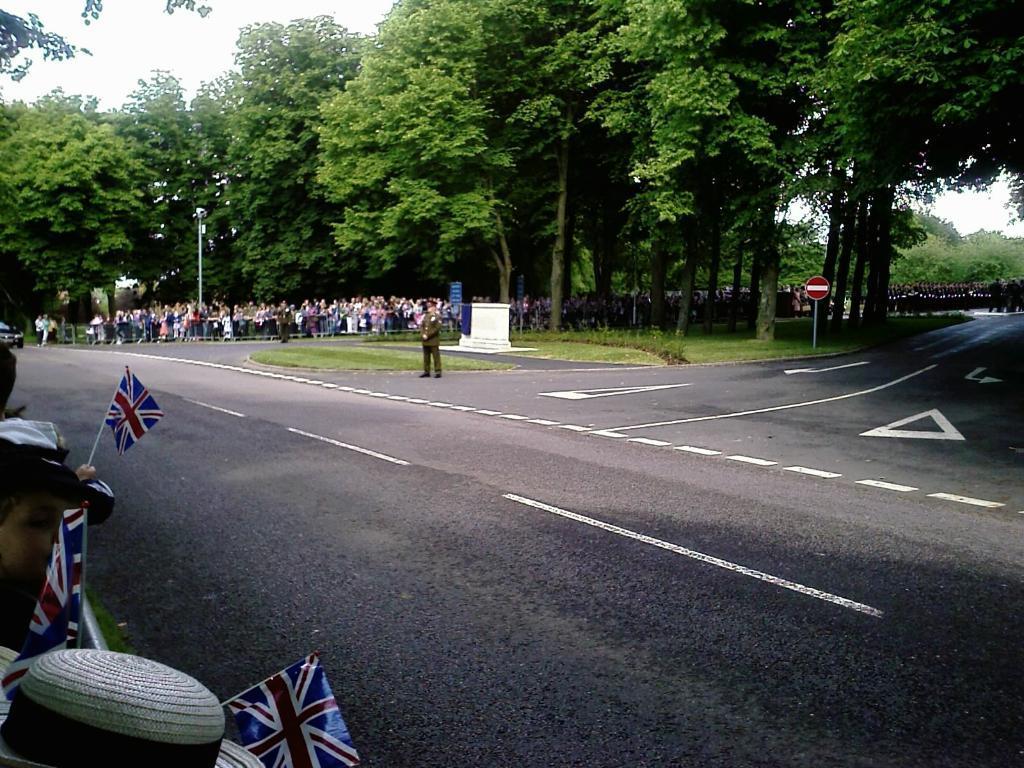Please provide a concise description of this image. In this image I can see the road. To the side of the road can see many people with different color dresses. I can see few people are holding the flags. I can also see the sign boards and light poles to the side. In the background there are many trees and the sky. 